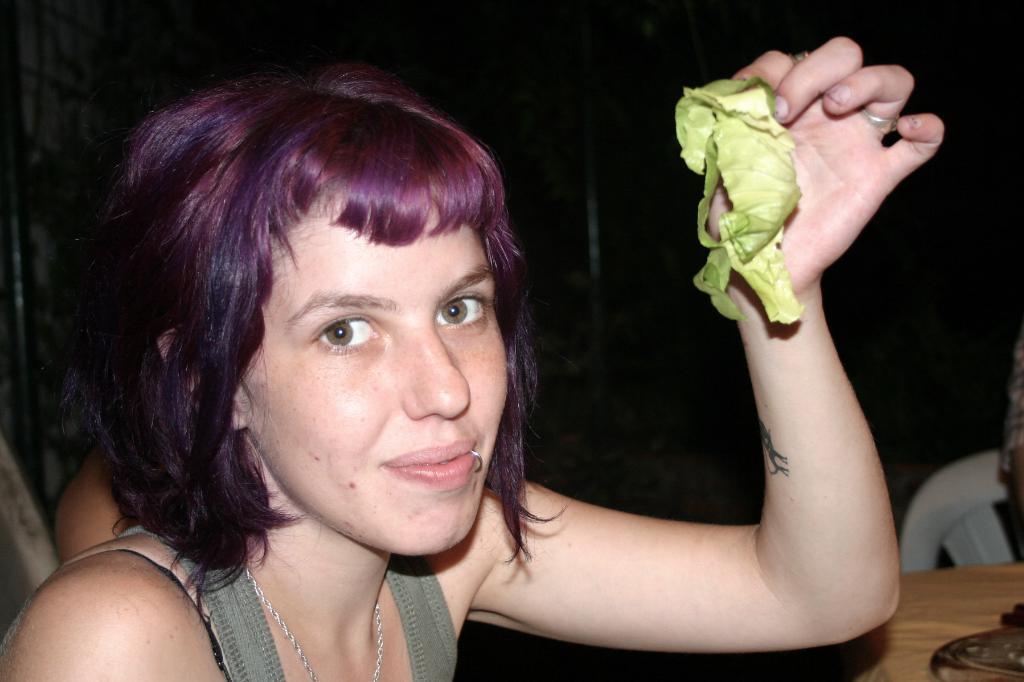Please provide a concise description of this image. There is a woman holding vegetable and we can see chair and object on the table. In the background it is dark. 